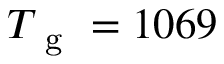Convert formula to latex. <formula><loc_0><loc_0><loc_500><loc_500>T _ { g } = 1 0 6 9</formula> 